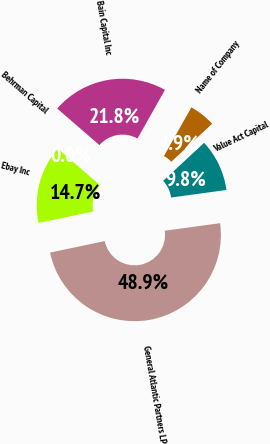Convert chart to OTSL. <chart><loc_0><loc_0><loc_500><loc_500><pie_chart><fcel>Name of Company<fcel>Bain Capital Inc<fcel>Behrman Capital<fcel>Ebay Inc<fcel>General Atlantic Partners LP<fcel>Value Act Capital<nl><fcel>4.89%<fcel>21.82%<fcel>0.0%<fcel>14.66%<fcel>48.86%<fcel>9.77%<nl></chart> 